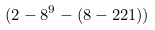Convert formula to latex. <formula><loc_0><loc_0><loc_500><loc_500>( 2 - 8 ^ { 9 } - ( 8 - 2 2 1 ) )</formula> 